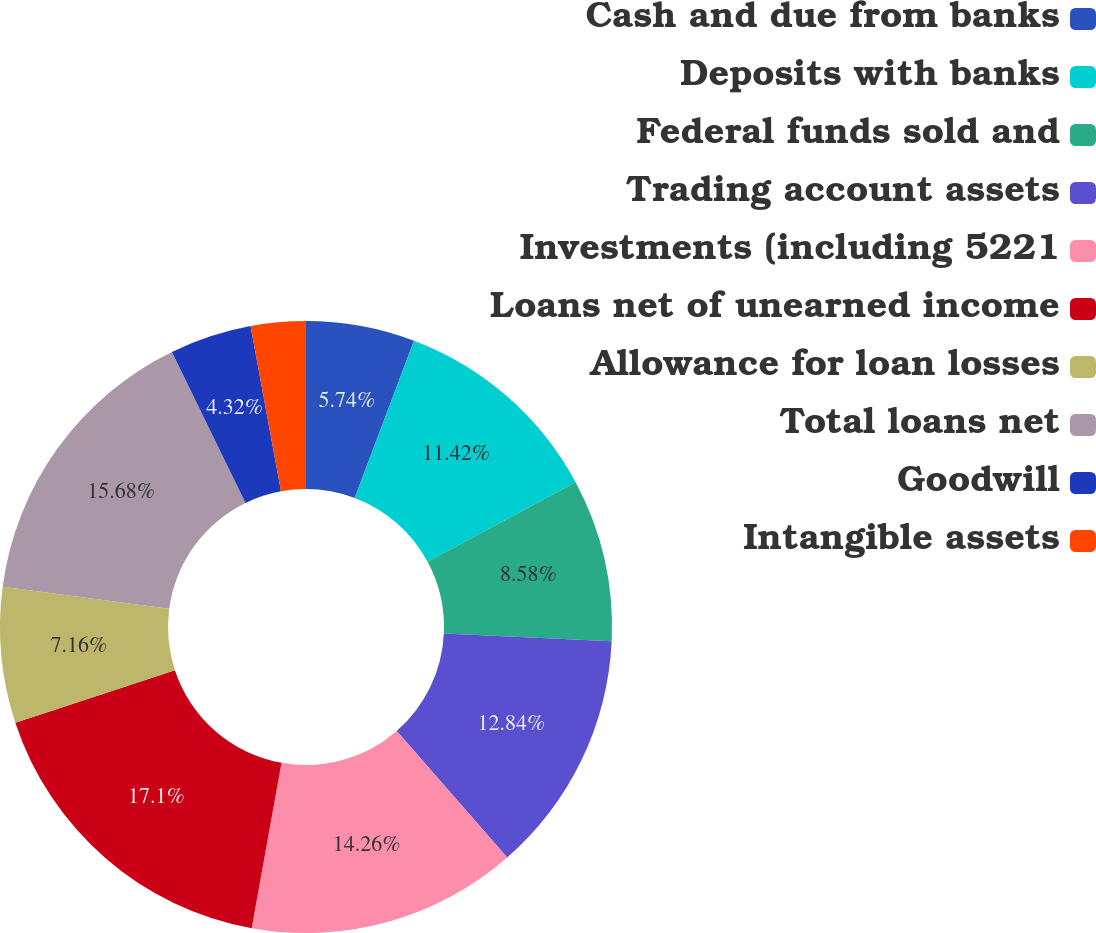<chart> <loc_0><loc_0><loc_500><loc_500><pie_chart><fcel>Cash and due from banks<fcel>Deposits with banks<fcel>Federal funds sold and<fcel>Trading account assets<fcel>Investments (including 5221<fcel>Loans net of unearned income<fcel>Allowance for loan losses<fcel>Total loans net<fcel>Goodwill<fcel>Intangible assets<nl><fcel>5.74%<fcel>11.42%<fcel>8.58%<fcel>12.84%<fcel>14.26%<fcel>17.1%<fcel>7.16%<fcel>15.68%<fcel>4.32%<fcel>2.9%<nl></chart> 